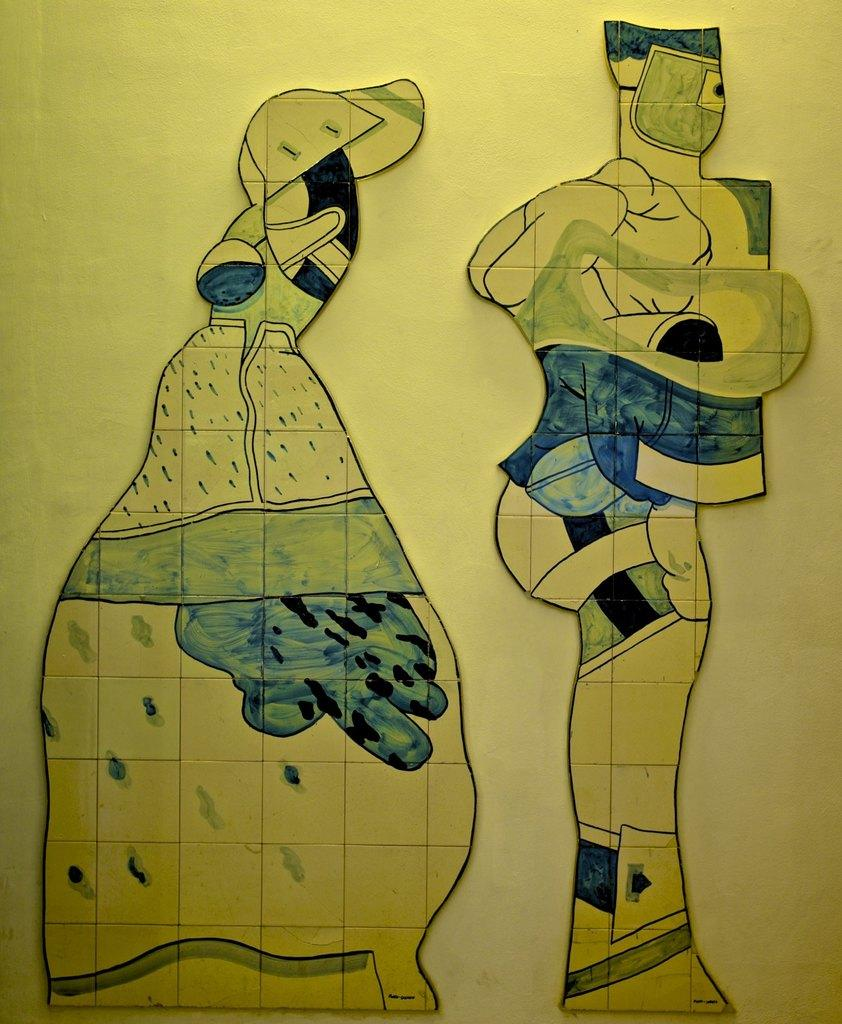What is the main subject of the image? There is a painting in the image. Can you describe the colors used in the painting? The painting has light green, blue, and black colors. What type of stocking is hanging on the furniture in the image? There is no furniture or stocking present in the image; it only features a painting with specific colors. 